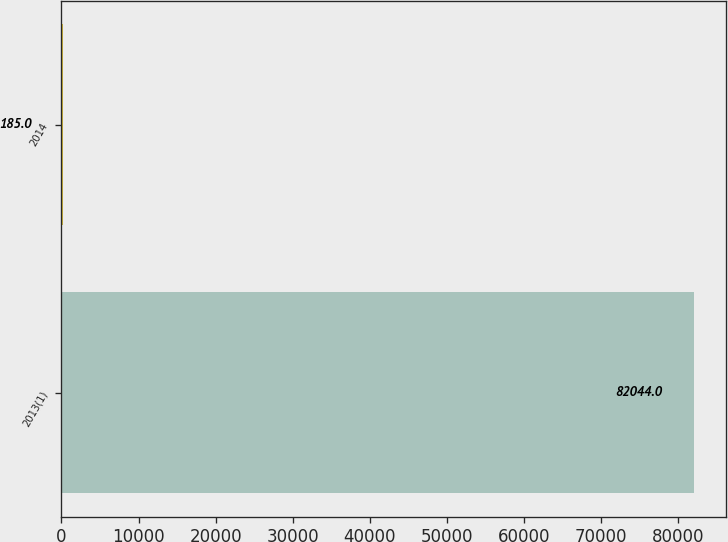Convert chart. <chart><loc_0><loc_0><loc_500><loc_500><bar_chart><fcel>2013(1)<fcel>2014<nl><fcel>82044<fcel>185<nl></chart> 